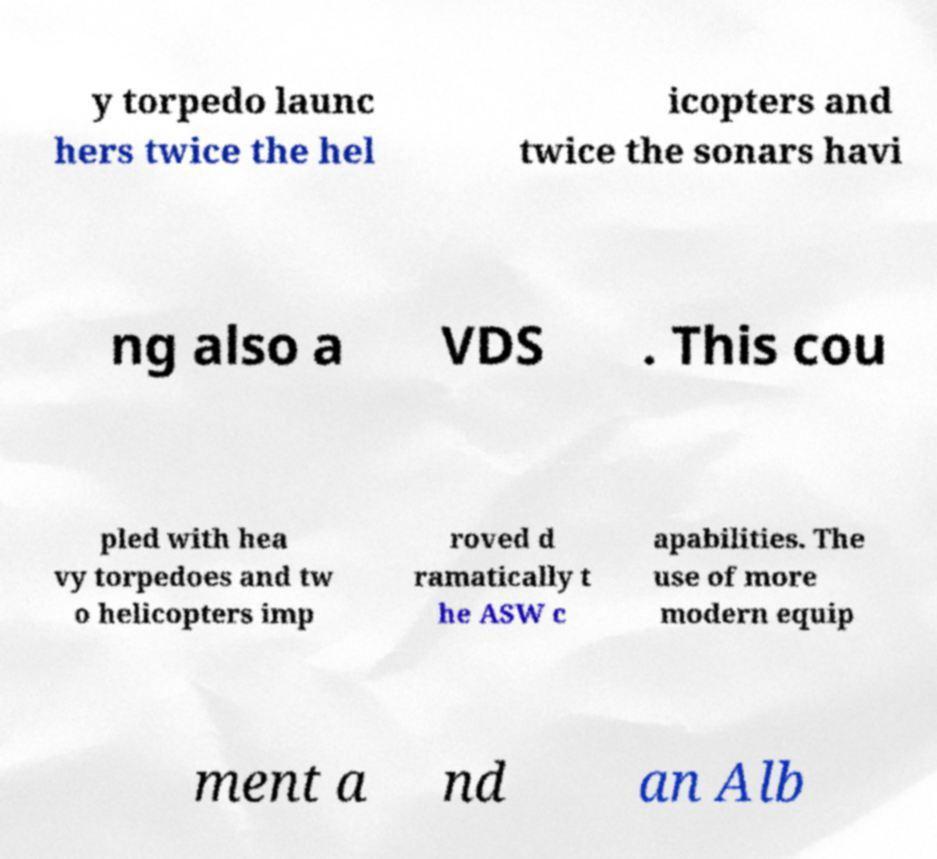Can you read and provide the text displayed in the image?This photo seems to have some interesting text. Can you extract and type it out for me? y torpedo launc hers twice the hel icopters and twice the sonars havi ng also a VDS . This cou pled with hea vy torpedoes and tw o helicopters imp roved d ramatically t he ASW c apabilities. The use of more modern equip ment a nd an Alb 